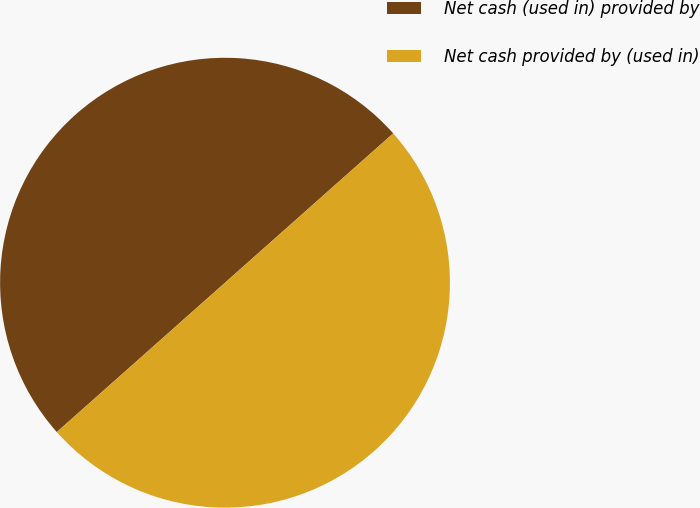Convert chart. <chart><loc_0><loc_0><loc_500><loc_500><pie_chart><fcel>Net cash (used in) provided by<fcel>Net cash provided by (used in)<nl><fcel>50.0%<fcel>50.0%<nl></chart> 